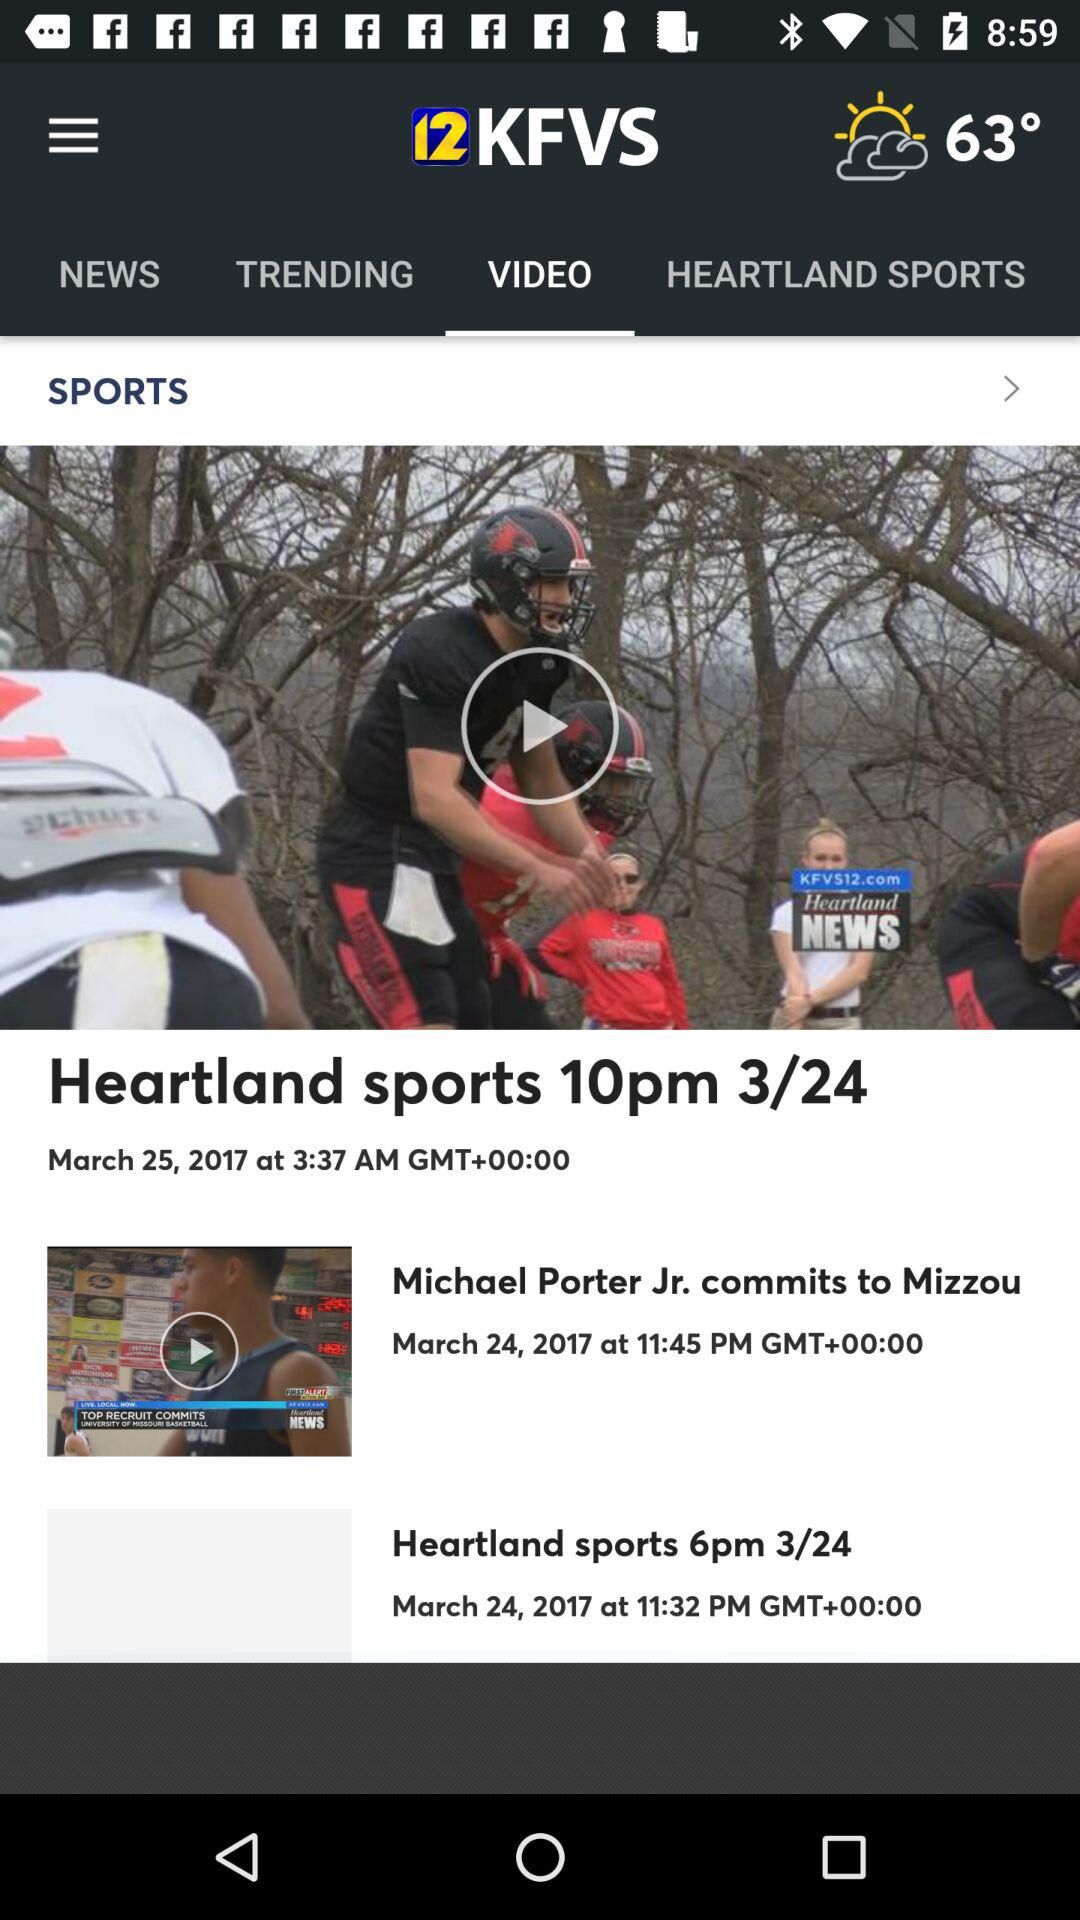When was the video "Heartland sports 10pm 3/24" posted? The video was posted on March 25, 2017 at 3:37 AM. 